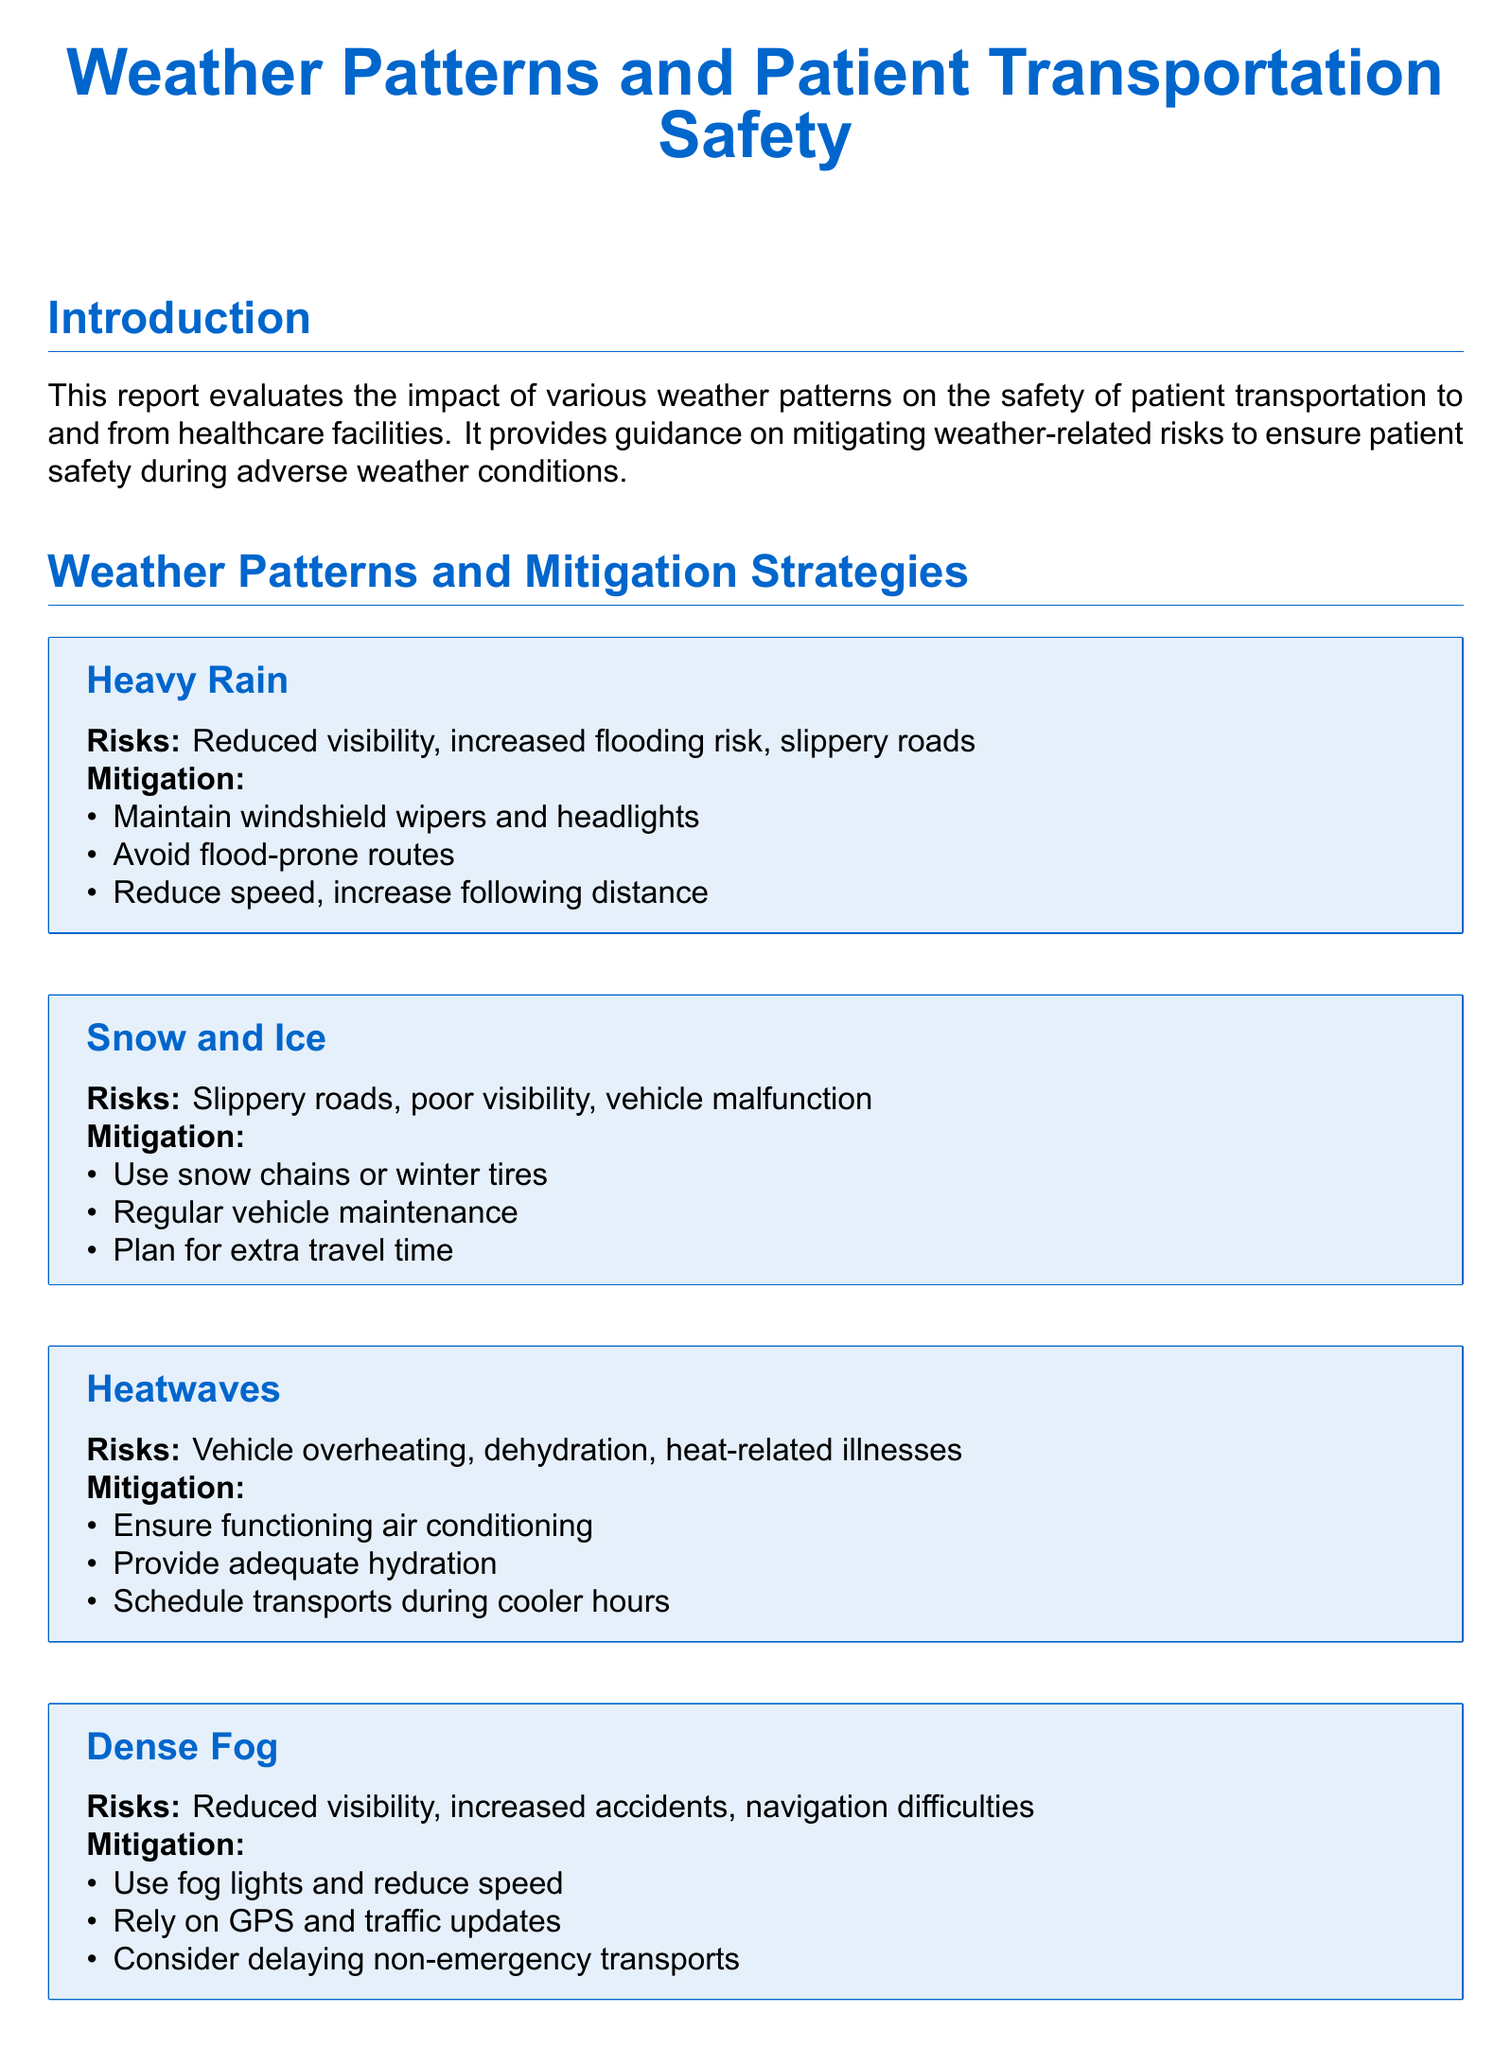What are the risks associated with heavy rain? The document lists reduced visibility, increased flooding risk, and slippery roads as the risks associated with heavy rain.
Answer: Reduced visibility, increased flooding risk, slippery roads What is one mitigation strategy for snow and ice? The document suggests using snow chains or winter tires as one of the mitigation strategies for snow and ice.
Answer: Use snow chains or winter tires What is a primary risk during heatwaves? The document identifies vehicle overheating as a primary risk during heatwaves.
Answer: Vehicle overheating What should be done during dense fog to enhance safety? The document advises using fog lights and reducing speed during dense fog to enhance safety.
Answer: Use fog lights and reduce speed What is necessary to maintain open communication with healthcare facilities? The document states that maintaining open communication is necessary to provide ongoing care and ensure patient safety.
Answer: Ongoing care and ensure patient safety What is one consideration for patient care during adverse weather? The document mentions continuous monitoring of critical patients as one consideration for patient care during adverse weather.
Answer: Continuous monitoring of critical patients How can patient transportation risks during adverse weather be minimized? The document concludes that proper planning and preparation can significantly reduce weather-related risks during patient transportation.
Answer: Proper planning and preparation What type of document is this? The document is a weather report assessing the impact of weather patterns on patient transportation safety.
Answer: Weather report 